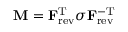Convert formula to latex. <formula><loc_0><loc_0><loc_500><loc_500>M = F _ { r e v } ^ { T } \sigma F _ { r e v } ^ { - T }</formula> 